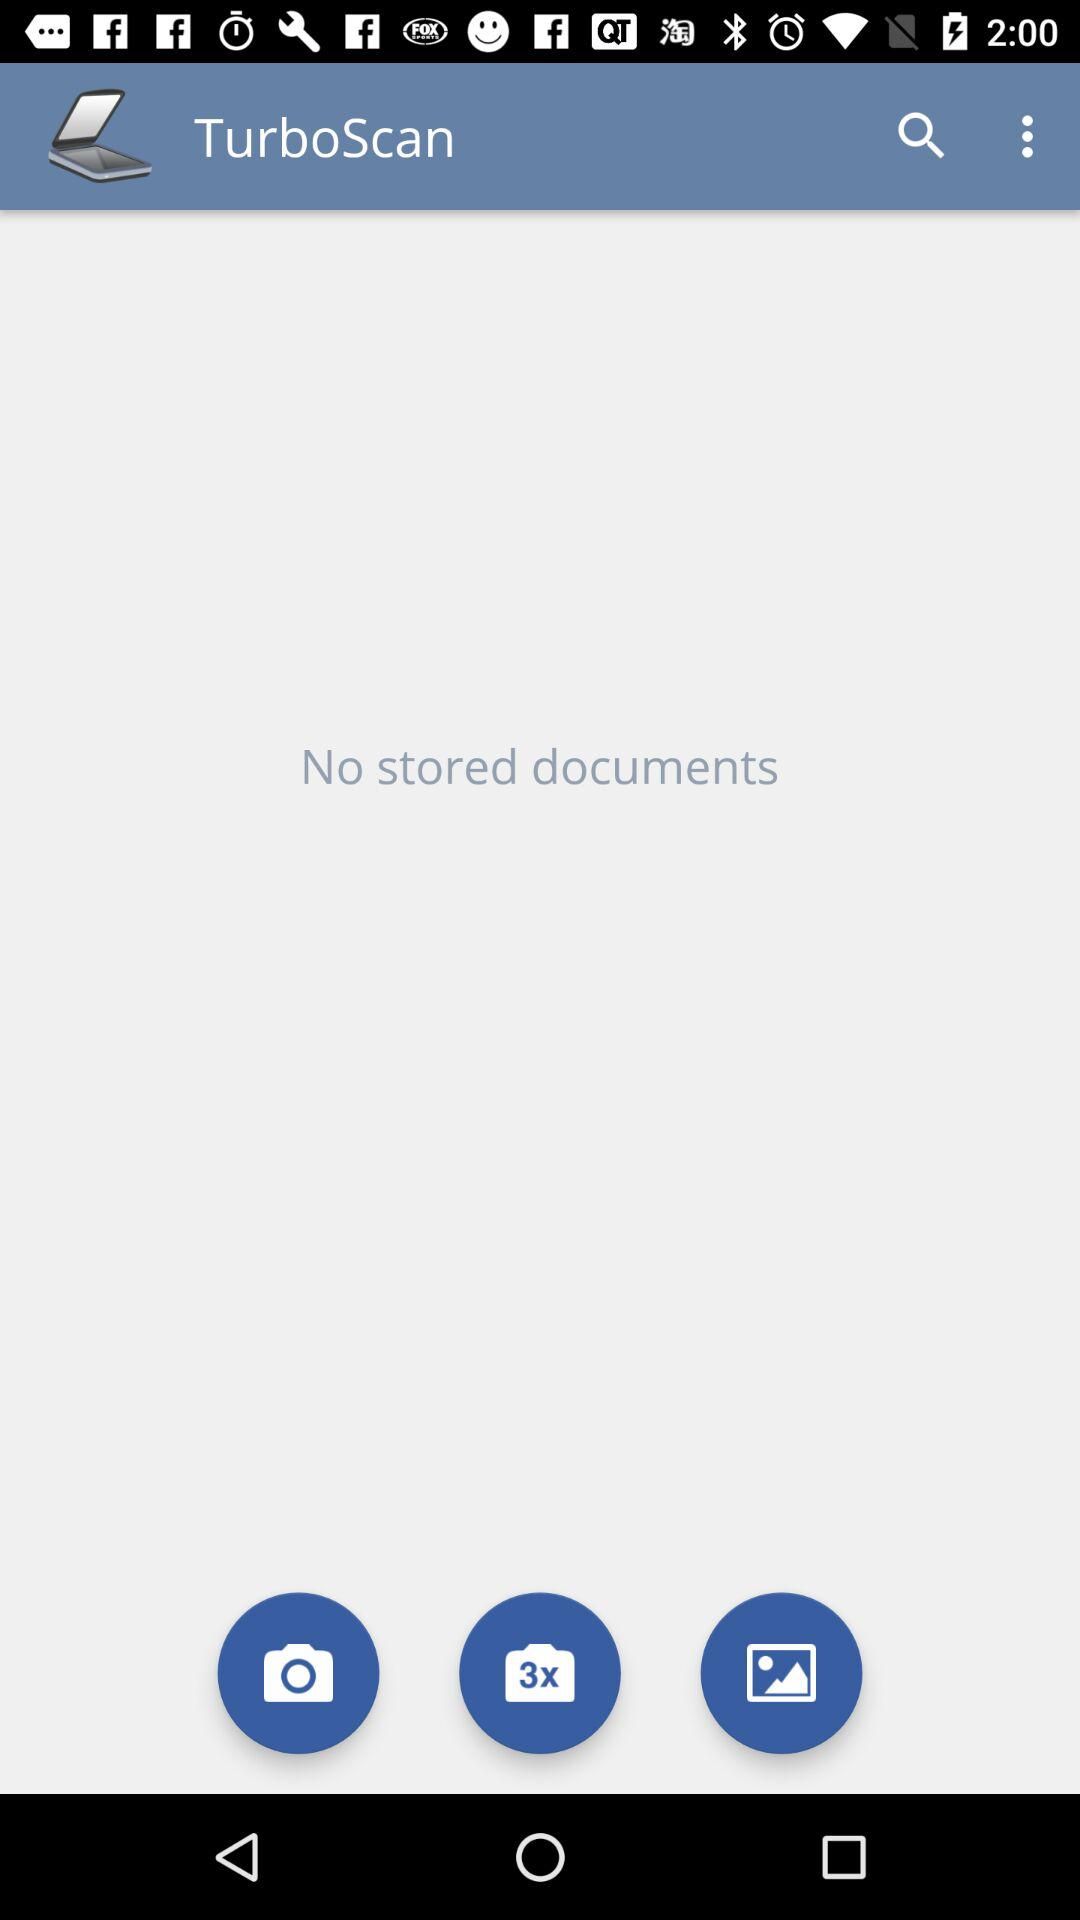What is the name of the application? The name of the application is "TurboScan". 